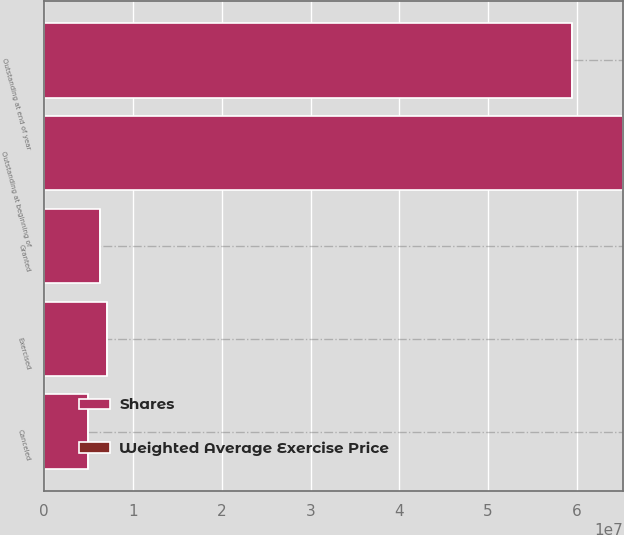Convert chart to OTSL. <chart><loc_0><loc_0><loc_500><loc_500><stacked_bar_chart><ecel><fcel>Outstanding at beginning of<fcel>Granted<fcel>Exercised<fcel>Canceled<fcel>Outstanding at end of year<nl><fcel>Shares<fcel>6.52275e+07<fcel>6.29878e+06<fcel>7.08842e+06<fcel>4.93368e+06<fcel>5.95042e+07<nl><fcel>Weighted Average Exercise Price<fcel>40.76<fcel>34.67<fcel>25.42<fcel>59.57<fcel>40.37<nl></chart> 